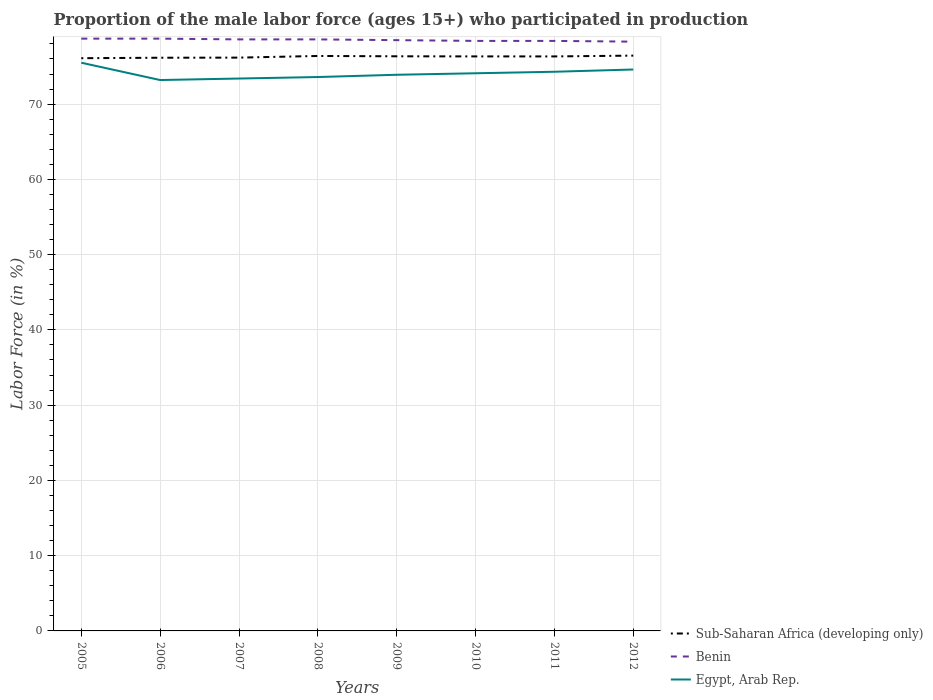Is the number of lines equal to the number of legend labels?
Keep it short and to the point. Yes. Across all years, what is the maximum proportion of the male labor force who participated in production in Egypt, Arab Rep.?
Keep it short and to the point. 73.2. What is the difference between the highest and the second highest proportion of the male labor force who participated in production in Sub-Saharan Africa (developing only)?
Your response must be concise. 0.34. What is the difference between the highest and the lowest proportion of the male labor force who participated in production in Sub-Saharan Africa (developing only)?
Ensure brevity in your answer.  5. Is the proportion of the male labor force who participated in production in Egypt, Arab Rep. strictly greater than the proportion of the male labor force who participated in production in Sub-Saharan Africa (developing only) over the years?
Offer a terse response. Yes. Does the graph contain grids?
Your answer should be very brief. Yes. Where does the legend appear in the graph?
Your response must be concise. Bottom right. How are the legend labels stacked?
Offer a terse response. Vertical. What is the title of the graph?
Keep it short and to the point. Proportion of the male labor force (ages 15+) who participated in production. What is the Labor Force (in %) of Sub-Saharan Africa (developing only) in 2005?
Your response must be concise. 76.1. What is the Labor Force (in %) of Benin in 2005?
Provide a succinct answer. 78.7. What is the Labor Force (in %) of Egypt, Arab Rep. in 2005?
Your answer should be very brief. 75.5. What is the Labor Force (in %) of Sub-Saharan Africa (developing only) in 2006?
Your answer should be compact. 76.16. What is the Labor Force (in %) in Benin in 2006?
Ensure brevity in your answer.  78.7. What is the Labor Force (in %) in Egypt, Arab Rep. in 2006?
Offer a terse response. 73.2. What is the Labor Force (in %) in Sub-Saharan Africa (developing only) in 2007?
Your answer should be compact. 76.18. What is the Labor Force (in %) in Benin in 2007?
Keep it short and to the point. 78.6. What is the Labor Force (in %) in Egypt, Arab Rep. in 2007?
Provide a succinct answer. 73.4. What is the Labor Force (in %) of Sub-Saharan Africa (developing only) in 2008?
Offer a terse response. 76.4. What is the Labor Force (in %) of Benin in 2008?
Provide a succinct answer. 78.6. What is the Labor Force (in %) of Egypt, Arab Rep. in 2008?
Ensure brevity in your answer.  73.6. What is the Labor Force (in %) in Sub-Saharan Africa (developing only) in 2009?
Provide a succinct answer. 76.35. What is the Labor Force (in %) in Benin in 2009?
Make the answer very short. 78.5. What is the Labor Force (in %) in Egypt, Arab Rep. in 2009?
Your answer should be compact. 73.9. What is the Labor Force (in %) of Sub-Saharan Africa (developing only) in 2010?
Your answer should be compact. 76.34. What is the Labor Force (in %) in Benin in 2010?
Your answer should be very brief. 78.4. What is the Labor Force (in %) in Egypt, Arab Rep. in 2010?
Offer a very short reply. 74.1. What is the Labor Force (in %) of Sub-Saharan Africa (developing only) in 2011?
Make the answer very short. 76.34. What is the Labor Force (in %) in Benin in 2011?
Your answer should be very brief. 78.4. What is the Labor Force (in %) of Egypt, Arab Rep. in 2011?
Give a very brief answer. 74.3. What is the Labor Force (in %) in Sub-Saharan Africa (developing only) in 2012?
Keep it short and to the point. 76.44. What is the Labor Force (in %) in Benin in 2012?
Provide a short and direct response. 78.3. What is the Labor Force (in %) in Egypt, Arab Rep. in 2012?
Ensure brevity in your answer.  74.6. Across all years, what is the maximum Labor Force (in %) in Sub-Saharan Africa (developing only)?
Provide a short and direct response. 76.44. Across all years, what is the maximum Labor Force (in %) of Benin?
Offer a terse response. 78.7. Across all years, what is the maximum Labor Force (in %) of Egypt, Arab Rep.?
Give a very brief answer. 75.5. Across all years, what is the minimum Labor Force (in %) in Sub-Saharan Africa (developing only)?
Provide a succinct answer. 76.1. Across all years, what is the minimum Labor Force (in %) in Benin?
Your answer should be very brief. 78.3. Across all years, what is the minimum Labor Force (in %) of Egypt, Arab Rep.?
Provide a succinct answer. 73.2. What is the total Labor Force (in %) of Sub-Saharan Africa (developing only) in the graph?
Provide a succinct answer. 610.32. What is the total Labor Force (in %) in Benin in the graph?
Offer a terse response. 628.2. What is the total Labor Force (in %) of Egypt, Arab Rep. in the graph?
Offer a very short reply. 592.6. What is the difference between the Labor Force (in %) of Sub-Saharan Africa (developing only) in 2005 and that in 2006?
Your answer should be very brief. -0.06. What is the difference between the Labor Force (in %) in Egypt, Arab Rep. in 2005 and that in 2006?
Your answer should be compact. 2.3. What is the difference between the Labor Force (in %) in Sub-Saharan Africa (developing only) in 2005 and that in 2007?
Offer a very short reply. -0.08. What is the difference between the Labor Force (in %) of Benin in 2005 and that in 2007?
Keep it short and to the point. 0.1. What is the difference between the Labor Force (in %) in Egypt, Arab Rep. in 2005 and that in 2007?
Your answer should be very brief. 2.1. What is the difference between the Labor Force (in %) of Sub-Saharan Africa (developing only) in 2005 and that in 2008?
Make the answer very short. -0.3. What is the difference between the Labor Force (in %) in Benin in 2005 and that in 2008?
Your answer should be very brief. 0.1. What is the difference between the Labor Force (in %) of Egypt, Arab Rep. in 2005 and that in 2008?
Your answer should be compact. 1.9. What is the difference between the Labor Force (in %) of Sub-Saharan Africa (developing only) in 2005 and that in 2009?
Your answer should be very brief. -0.25. What is the difference between the Labor Force (in %) of Sub-Saharan Africa (developing only) in 2005 and that in 2010?
Offer a very short reply. -0.24. What is the difference between the Labor Force (in %) of Benin in 2005 and that in 2010?
Offer a very short reply. 0.3. What is the difference between the Labor Force (in %) in Egypt, Arab Rep. in 2005 and that in 2010?
Your response must be concise. 1.4. What is the difference between the Labor Force (in %) in Sub-Saharan Africa (developing only) in 2005 and that in 2011?
Offer a terse response. -0.24. What is the difference between the Labor Force (in %) of Egypt, Arab Rep. in 2005 and that in 2011?
Give a very brief answer. 1.2. What is the difference between the Labor Force (in %) of Sub-Saharan Africa (developing only) in 2005 and that in 2012?
Ensure brevity in your answer.  -0.34. What is the difference between the Labor Force (in %) of Benin in 2005 and that in 2012?
Make the answer very short. 0.4. What is the difference between the Labor Force (in %) of Sub-Saharan Africa (developing only) in 2006 and that in 2007?
Your answer should be compact. -0.02. What is the difference between the Labor Force (in %) of Benin in 2006 and that in 2007?
Give a very brief answer. 0.1. What is the difference between the Labor Force (in %) in Sub-Saharan Africa (developing only) in 2006 and that in 2008?
Make the answer very short. -0.24. What is the difference between the Labor Force (in %) in Egypt, Arab Rep. in 2006 and that in 2008?
Provide a succinct answer. -0.4. What is the difference between the Labor Force (in %) in Sub-Saharan Africa (developing only) in 2006 and that in 2009?
Your answer should be compact. -0.19. What is the difference between the Labor Force (in %) in Egypt, Arab Rep. in 2006 and that in 2009?
Offer a terse response. -0.7. What is the difference between the Labor Force (in %) in Sub-Saharan Africa (developing only) in 2006 and that in 2010?
Ensure brevity in your answer.  -0.18. What is the difference between the Labor Force (in %) in Benin in 2006 and that in 2010?
Provide a short and direct response. 0.3. What is the difference between the Labor Force (in %) of Sub-Saharan Africa (developing only) in 2006 and that in 2011?
Make the answer very short. -0.17. What is the difference between the Labor Force (in %) in Sub-Saharan Africa (developing only) in 2006 and that in 2012?
Your response must be concise. -0.28. What is the difference between the Labor Force (in %) in Sub-Saharan Africa (developing only) in 2007 and that in 2008?
Keep it short and to the point. -0.22. What is the difference between the Labor Force (in %) of Benin in 2007 and that in 2008?
Ensure brevity in your answer.  0. What is the difference between the Labor Force (in %) of Sub-Saharan Africa (developing only) in 2007 and that in 2009?
Provide a succinct answer. -0.18. What is the difference between the Labor Force (in %) in Benin in 2007 and that in 2009?
Give a very brief answer. 0.1. What is the difference between the Labor Force (in %) in Egypt, Arab Rep. in 2007 and that in 2009?
Give a very brief answer. -0.5. What is the difference between the Labor Force (in %) in Sub-Saharan Africa (developing only) in 2007 and that in 2010?
Ensure brevity in your answer.  -0.16. What is the difference between the Labor Force (in %) in Egypt, Arab Rep. in 2007 and that in 2010?
Provide a succinct answer. -0.7. What is the difference between the Labor Force (in %) of Sub-Saharan Africa (developing only) in 2007 and that in 2011?
Your answer should be very brief. -0.16. What is the difference between the Labor Force (in %) of Egypt, Arab Rep. in 2007 and that in 2011?
Keep it short and to the point. -0.9. What is the difference between the Labor Force (in %) in Sub-Saharan Africa (developing only) in 2007 and that in 2012?
Your answer should be very brief. -0.27. What is the difference between the Labor Force (in %) of Egypt, Arab Rep. in 2007 and that in 2012?
Ensure brevity in your answer.  -1.2. What is the difference between the Labor Force (in %) of Sub-Saharan Africa (developing only) in 2008 and that in 2009?
Provide a succinct answer. 0.04. What is the difference between the Labor Force (in %) of Egypt, Arab Rep. in 2008 and that in 2009?
Your response must be concise. -0.3. What is the difference between the Labor Force (in %) in Sub-Saharan Africa (developing only) in 2008 and that in 2010?
Give a very brief answer. 0.06. What is the difference between the Labor Force (in %) of Sub-Saharan Africa (developing only) in 2008 and that in 2011?
Your response must be concise. 0.06. What is the difference between the Labor Force (in %) in Egypt, Arab Rep. in 2008 and that in 2011?
Your answer should be very brief. -0.7. What is the difference between the Labor Force (in %) of Sub-Saharan Africa (developing only) in 2008 and that in 2012?
Provide a short and direct response. -0.05. What is the difference between the Labor Force (in %) in Benin in 2008 and that in 2012?
Make the answer very short. 0.3. What is the difference between the Labor Force (in %) of Sub-Saharan Africa (developing only) in 2009 and that in 2010?
Offer a very short reply. 0.01. What is the difference between the Labor Force (in %) of Egypt, Arab Rep. in 2009 and that in 2010?
Your response must be concise. -0.2. What is the difference between the Labor Force (in %) of Sub-Saharan Africa (developing only) in 2009 and that in 2011?
Provide a short and direct response. 0.02. What is the difference between the Labor Force (in %) in Benin in 2009 and that in 2011?
Your answer should be compact. 0.1. What is the difference between the Labor Force (in %) in Egypt, Arab Rep. in 2009 and that in 2011?
Keep it short and to the point. -0.4. What is the difference between the Labor Force (in %) of Sub-Saharan Africa (developing only) in 2009 and that in 2012?
Keep it short and to the point. -0.09. What is the difference between the Labor Force (in %) in Benin in 2009 and that in 2012?
Make the answer very short. 0.2. What is the difference between the Labor Force (in %) of Egypt, Arab Rep. in 2009 and that in 2012?
Your response must be concise. -0.7. What is the difference between the Labor Force (in %) of Sub-Saharan Africa (developing only) in 2010 and that in 2011?
Ensure brevity in your answer.  0. What is the difference between the Labor Force (in %) of Benin in 2010 and that in 2011?
Offer a terse response. 0. What is the difference between the Labor Force (in %) of Sub-Saharan Africa (developing only) in 2010 and that in 2012?
Your response must be concise. -0.1. What is the difference between the Labor Force (in %) in Benin in 2010 and that in 2012?
Offer a terse response. 0.1. What is the difference between the Labor Force (in %) in Sub-Saharan Africa (developing only) in 2011 and that in 2012?
Your answer should be compact. -0.11. What is the difference between the Labor Force (in %) in Benin in 2011 and that in 2012?
Your answer should be compact. 0.1. What is the difference between the Labor Force (in %) in Egypt, Arab Rep. in 2011 and that in 2012?
Offer a terse response. -0.3. What is the difference between the Labor Force (in %) of Sub-Saharan Africa (developing only) in 2005 and the Labor Force (in %) of Benin in 2006?
Provide a succinct answer. -2.6. What is the difference between the Labor Force (in %) of Sub-Saharan Africa (developing only) in 2005 and the Labor Force (in %) of Egypt, Arab Rep. in 2006?
Your answer should be compact. 2.9. What is the difference between the Labor Force (in %) of Sub-Saharan Africa (developing only) in 2005 and the Labor Force (in %) of Benin in 2007?
Make the answer very short. -2.5. What is the difference between the Labor Force (in %) of Sub-Saharan Africa (developing only) in 2005 and the Labor Force (in %) of Egypt, Arab Rep. in 2007?
Offer a terse response. 2.7. What is the difference between the Labor Force (in %) in Benin in 2005 and the Labor Force (in %) in Egypt, Arab Rep. in 2007?
Your response must be concise. 5.3. What is the difference between the Labor Force (in %) of Sub-Saharan Africa (developing only) in 2005 and the Labor Force (in %) of Benin in 2008?
Make the answer very short. -2.5. What is the difference between the Labor Force (in %) of Sub-Saharan Africa (developing only) in 2005 and the Labor Force (in %) of Egypt, Arab Rep. in 2008?
Your answer should be very brief. 2.5. What is the difference between the Labor Force (in %) in Sub-Saharan Africa (developing only) in 2005 and the Labor Force (in %) in Benin in 2009?
Offer a very short reply. -2.4. What is the difference between the Labor Force (in %) in Sub-Saharan Africa (developing only) in 2005 and the Labor Force (in %) in Egypt, Arab Rep. in 2009?
Your response must be concise. 2.2. What is the difference between the Labor Force (in %) of Sub-Saharan Africa (developing only) in 2005 and the Labor Force (in %) of Benin in 2010?
Your answer should be compact. -2.3. What is the difference between the Labor Force (in %) in Sub-Saharan Africa (developing only) in 2005 and the Labor Force (in %) in Egypt, Arab Rep. in 2010?
Provide a short and direct response. 2. What is the difference between the Labor Force (in %) in Sub-Saharan Africa (developing only) in 2005 and the Labor Force (in %) in Benin in 2011?
Make the answer very short. -2.3. What is the difference between the Labor Force (in %) in Sub-Saharan Africa (developing only) in 2005 and the Labor Force (in %) in Egypt, Arab Rep. in 2011?
Give a very brief answer. 1.8. What is the difference between the Labor Force (in %) in Benin in 2005 and the Labor Force (in %) in Egypt, Arab Rep. in 2011?
Your answer should be compact. 4.4. What is the difference between the Labor Force (in %) in Sub-Saharan Africa (developing only) in 2005 and the Labor Force (in %) in Benin in 2012?
Keep it short and to the point. -2.2. What is the difference between the Labor Force (in %) in Sub-Saharan Africa (developing only) in 2005 and the Labor Force (in %) in Egypt, Arab Rep. in 2012?
Your answer should be very brief. 1.5. What is the difference between the Labor Force (in %) of Benin in 2005 and the Labor Force (in %) of Egypt, Arab Rep. in 2012?
Your response must be concise. 4.1. What is the difference between the Labor Force (in %) in Sub-Saharan Africa (developing only) in 2006 and the Labor Force (in %) in Benin in 2007?
Offer a terse response. -2.44. What is the difference between the Labor Force (in %) in Sub-Saharan Africa (developing only) in 2006 and the Labor Force (in %) in Egypt, Arab Rep. in 2007?
Offer a very short reply. 2.76. What is the difference between the Labor Force (in %) of Sub-Saharan Africa (developing only) in 2006 and the Labor Force (in %) of Benin in 2008?
Make the answer very short. -2.44. What is the difference between the Labor Force (in %) of Sub-Saharan Africa (developing only) in 2006 and the Labor Force (in %) of Egypt, Arab Rep. in 2008?
Make the answer very short. 2.56. What is the difference between the Labor Force (in %) in Sub-Saharan Africa (developing only) in 2006 and the Labor Force (in %) in Benin in 2009?
Provide a short and direct response. -2.34. What is the difference between the Labor Force (in %) of Sub-Saharan Africa (developing only) in 2006 and the Labor Force (in %) of Egypt, Arab Rep. in 2009?
Make the answer very short. 2.26. What is the difference between the Labor Force (in %) in Sub-Saharan Africa (developing only) in 2006 and the Labor Force (in %) in Benin in 2010?
Provide a short and direct response. -2.24. What is the difference between the Labor Force (in %) in Sub-Saharan Africa (developing only) in 2006 and the Labor Force (in %) in Egypt, Arab Rep. in 2010?
Your answer should be very brief. 2.06. What is the difference between the Labor Force (in %) in Benin in 2006 and the Labor Force (in %) in Egypt, Arab Rep. in 2010?
Keep it short and to the point. 4.6. What is the difference between the Labor Force (in %) in Sub-Saharan Africa (developing only) in 2006 and the Labor Force (in %) in Benin in 2011?
Give a very brief answer. -2.24. What is the difference between the Labor Force (in %) in Sub-Saharan Africa (developing only) in 2006 and the Labor Force (in %) in Egypt, Arab Rep. in 2011?
Provide a short and direct response. 1.86. What is the difference between the Labor Force (in %) of Benin in 2006 and the Labor Force (in %) of Egypt, Arab Rep. in 2011?
Give a very brief answer. 4.4. What is the difference between the Labor Force (in %) in Sub-Saharan Africa (developing only) in 2006 and the Labor Force (in %) in Benin in 2012?
Your answer should be very brief. -2.14. What is the difference between the Labor Force (in %) of Sub-Saharan Africa (developing only) in 2006 and the Labor Force (in %) of Egypt, Arab Rep. in 2012?
Your answer should be compact. 1.56. What is the difference between the Labor Force (in %) of Sub-Saharan Africa (developing only) in 2007 and the Labor Force (in %) of Benin in 2008?
Provide a succinct answer. -2.42. What is the difference between the Labor Force (in %) in Sub-Saharan Africa (developing only) in 2007 and the Labor Force (in %) in Egypt, Arab Rep. in 2008?
Make the answer very short. 2.58. What is the difference between the Labor Force (in %) of Sub-Saharan Africa (developing only) in 2007 and the Labor Force (in %) of Benin in 2009?
Offer a terse response. -2.32. What is the difference between the Labor Force (in %) in Sub-Saharan Africa (developing only) in 2007 and the Labor Force (in %) in Egypt, Arab Rep. in 2009?
Give a very brief answer. 2.28. What is the difference between the Labor Force (in %) of Benin in 2007 and the Labor Force (in %) of Egypt, Arab Rep. in 2009?
Your answer should be very brief. 4.7. What is the difference between the Labor Force (in %) in Sub-Saharan Africa (developing only) in 2007 and the Labor Force (in %) in Benin in 2010?
Your answer should be very brief. -2.22. What is the difference between the Labor Force (in %) in Sub-Saharan Africa (developing only) in 2007 and the Labor Force (in %) in Egypt, Arab Rep. in 2010?
Your response must be concise. 2.08. What is the difference between the Labor Force (in %) in Benin in 2007 and the Labor Force (in %) in Egypt, Arab Rep. in 2010?
Give a very brief answer. 4.5. What is the difference between the Labor Force (in %) of Sub-Saharan Africa (developing only) in 2007 and the Labor Force (in %) of Benin in 2011?
Make the answer very short. -2.22. What is the difference between the Labor Force (in %) of Sub-Saharan Africa (developing only) in 2007 and the Labor Force (in %) of Egypt, Arab Rep. in 2011?
Keep it short and to the point. 1.88. What is the difference between the Labor Force (in %) of Sub-Saharan Africa (developing only) in 2007 and the Labor Force (in %) of Benin in 2012?
Your answer should be very brief. -2.12. What is the difference between the Labor Force (in %) of Sub-Saharan Africa (developing only) in 2007 and the Labor Force (in %) of Egypt, Arab Rep. in 2012?
Your answer should be compact. 1.58. What is the difference between the Labor Force (in %) of Benin in 2007 and the Labor Force (in %) of Egypt, Arab Rep. in 2012?
Offer a terse response. 4. What is the difference between the Labor Force (in %) in Sub-Saharan Africa (developing only) in 2008 and the Labor Force (in %) in Benin in 2009?
Ensure brevity in your answer.  -2.1. What is the difference between the Labor Force (in %) in Sub-Saharan Africa (developing only) in 2008 and the Labor Force (in %) in Egypt, Arab Rep. in 2009?
Provide a succinct answer. 2.5. What is the difference between the Labor Force (in %) in Benin in 2008 and the Labor Force (in %) in Egypt, Arab Rep. in 2009?
Offer a very short reply. 4.7. What is the difference between the Labor Force (in %) of Sub-Saharan Africa (developing only) in 2008 and the Labor Force (in %) of Benin in 2010?
Offer a terse response. -2. What is the difference between the Labor Force (in %) in Sub-Saharan Africa (developing only) in 2008 and the Labor Force (in %) in Egypt, Arab Rep. in 2010?
Ensure brevity in your answer.  2.3. What is the difference between the Labor Force (in %) in Benin in 2008 and the Labor Force (in %) in Egypt, Arab Rep. in 2010?
Offer a terse response. 4.5. What is the difference between the Labor Force (in %) of Sub-Saharan Africa (developing only) in 2008 and the Labor Force (in %) of Benin in 2011?
Offer a terse response. -2. What is the difference between the Labor Force (in %) of Sub-Saharan Africa (developing only) in 2008 and the Labor Force (in %) of Egypt, Arab Rep. in 2011?
Ensure brevity in your answer.  2.1. What is the difference between the Labor Force (in %) of Benin in 2008 and the Labor Force (in %) of Egypt, Arab Rep. in 2011?
Keep it short and to the point. 4.3. What is the difference between the Labor Force (in %) in Sub-Saharan Africa (developing only) in 2008 and the Labor Force (in %) in Benin in 2012?
Make the answer very short. -1.9. What is the difference between the Labor Force (in %) of Sub-Saharan Africa (developing only) in 2008 and the Labor Force (in %) of Egypt, Arab Rep. in 2012?
Your answer should be compact. 1.8. What is the difference between the Labor Force (in %) of Benin in 2008 and the Labor Force (in %) of Egypt, Arab Rep. in 2012?
Make the answer very short. 4. What is the difference between the Labor Force (in %) of Sub-Saharan Africa (developing only) in 2009 and the Labor Force (in %) of Benin in 2010?
Offer a very short reply. -2.05. What is the difference between the Labor Force (in %) of Sub-Saharan Africa (developing only) in 2009 and the Labor Force (in %) of Egypt, Arab Rep. in 2010?
Your answer should be very brief. 2.25. What is the difference between the Labor Force (in %) of Benin in 2009 and the Labor Force (in %) of Egypt, Arab Rep. in 2010?
Your answer should be compact. 4.4. What is the difference between the Labor Force (in %) of Sub-Saharan Africa (developing only) in 2009 and the Labor Force (in %) of Benin in 2011?
Give a very brief answer. -2.05. What is the difference between the Labor Force (in %) in Sub-Saharan Africa (developing only) in 2009 and the Labor Force (in %) in Egypt, Arab Rep. in 2011?
Your response must be concise. 2.05. What is the difference between the Labor Force (in %) in Benin in 2009 and the Labor Force (in %) in Egypt, Arab Rep. in 2011?
Provide a succinct answer. 4.2. What is the difference between the Labor Force (in %) of Sub-Saharan Africa (developing only) in 2009 and the Labor Force (in %) of Benin in 2012?
Keep it short and to the point. -1.95. What is the difference between the Labor Force (in %) in Sub-Saharan Africa (developing only) in 2009 and the Labor Force (in %) in Egypt, Arab Rep. in 2012?
Your response must be concise. 1.75. What is the difference between the Labor Force (in %) in Sub-Saharan Africa (developing only) in 2010 and the Labor Force (in %) in Benin in 2011?
Make the answer very short. -2.06. What is the difference between the Labor Force (in %) in Sub-Saharan Africa (developing only) in 2010 and the Labor Force (in %) in Egypt, Arab Rep. in 2011?
Give a very brief answer. 2.04. What is the difference between the Labor Force (in %) in Sub-Saharan Africa (developing only) in 2010 and the Labor Force (in %) in Benin in 2012?
Give a very brief answer. -1.96. What is the difference between the Labor Force (in %) in Sub-Saharan Africa (developing only) in 2010 and the Labor Force (in %) in Egypt, Arab Rep. in 2012?
Your response must be concise. 1.74. What is the difference between the Labor Force (in %) in Benin in 2010 and the Labor Force (in %) in Egypt, Arab Rep. in 2012?
Provide a succinct answer. 3.8. What is the difference between the Labor Force (in %) in Sub-Saharan Africa (developing only) in 2011 and the Labor Force (in %) in Benin in 2012?
Give a very brief answer. -1.96. What is the difference between the Labor Force (in %) in Sub-Saharan Africa (developing only) in 2011 and the Labor Force (in %) in Egypt, Arab Rep. in 2012?
Your answer should be very brief. 1.74. What is the difference between the Labor Force (in %) in Benin in 2011 and the Labor Force (in %) in Egypt, Arab Rep. in 2012?
Make the answer very short. 3.8. What is the average Labor Force (in %) of Sub-Saharan Africa (developing only) per year?
Make the answer very short. 76.29. What is the average Labor Force (in %) in Benin per year?
Your response must be concise. 78.53. What is the average Labor Force (in %) in Egypt, Arab Rep. per year?
Provide a succinct answer. 74.08. In the year 2005, what is the difference between the Labor Force (in %) of Sub-Saharan Africa (developing only) and Labor Force (in %) of Benin?
Make the answer very short. -2.6. In the year 2005, what is the difference between the Labor Force (in %) of Sub-Saharan Africa (developing only) and Labor Force (in %) of Egypt, Arab Rep.?
Ensure brevity in your answer.  0.6. In the year 2006, what is the difference between the Labor Force (in %) of Sub-Saharan Africa (developing only) and Labor Force (in %) of Benin?
Your answer should be very brief. -2.54. In the year 2006, what is the difference between the Labor Force (in %) in Sub-Saharan Africa (developing only) and Labor Force (in %) in Egypt, Arab Rep.?
Provide a short and direct response. 2.96. In the year 2007, what is the difference between the Labor Force (in %) of Sub-Saharan Africa (developing only) and Labor Force (in %) of Benin?
Make the answer very short. -2.42. In the year 2007, what is the difference between the Labor Force (in %) of Sub-Saharan Africa (developing only) and Labor Force (in %) of Egypt, Arab Rep.?
Provide a succinct answer. 2.78. In the year 2007, what is the difference between the Labor Force (in %) in Benin and Labor Force (in %) in Egypt, Arab Rep.?
Your answer should be very brief. 5.2. In the year 2008, what is the difference between the Labor Force (in %) of Sub-Saharan Africa (developing only) and Labor Force (in %) of Benin?
Make the answer very short. -2.2. In the year 2008, what is the difference between the Labor Force (in %) in Sub-Saharan Africa (developing only) and Labor Force (in %) in Egypt, Arab Rep.?
Keep it short and to the point. 2.8. In the year 2008, what is the difference between the Labor Force (in %) of Benin and Labor Force (in %) of Egypt, Arab Rep.?
Your answer should be compact. 5. In the year 2009, what is the difference between the Labor Force (in %) of Sub-Saharan Africa (developing only) and Labor Force (in %) of Benin?
Give a very brief answer. -2.15. In the year 2009, what is the difference between the Labor Force (in %) in Sub-Saharan Africa (developing only) and Labor Force (in %) in Egypt, Arab Rep.?
Offer a terse response. 2.45. In the year 2009, what is the difference between the Labor Force (in %) in Benin and Labor Force (in %) in Egypt, Arab Rep.?
Give a very brief answer. 4.6. In the year 2010, what is the difference between the Labor Force (in %) of Sub-Saharan Africa (developing only) and Labor Force (in %) of Benin?
Give a very brief answer. -2.06. In the year 2010, what is the difference between the Labor Force (in %) of Sub-Saharan Africa (developing only) and Labor Force (in %) of Egypt, Arab Rep.?
Make the answer very short. 2.24. In the year 2011, what is the difference between the Labor Force (in %) of Sub-Saharan Africa (developing only) and Labor Force (in %) of Benin?
Make the answer very short. -2.06. In the year 2011, what is the difference between the Labor Force (in %) of Sub-Saharan Africa (developing only) and Labor Force (in %) of Egypt, Arab Rep.?
Your answer should be very brief. 2.04. In the year 2012, what is the difference between the Labor Force (in %) in Sub-Saharan Africa (developing only) and Labor Force (in %) in Benin?
Provide a succinct answer. -1.86. In the year 2012, what is the difference between the Labor Force (in %) in Sub-Saharan Africa (developing only) and Labor Force (in %) in Egypt, Arab Rep.?
Your answer should be very brief. 1.84. What is the ratio of the Labor Force (in %) in Benin in 2005 to that in 2006?
Make the answer very short. 1. What is the ratio of the Labor Force (in %) in Egypt, Arab Rep. in 2005 to that in 2006?
Your answer should be compact. 1.03. What is the ratio of the Labor Force (in %) of Sub-Saharan Africa (developing only) in 2005 to that in 2007?
Offer a terse response. 1. What is the ratio of the Labor Force (in %) of Egypt, Arab Rep. in 2005 to that in 2007?
Your answer should be very brief. 1.03. What is the ratio of the Labor Force (in %) in Sub-Saharan Africa (developing only) in 2005 to that in 2008?
Keep it short and to the point. 1. What is the ratio of the Labor Force (in %) in Benin in 2005 to that in 2008?
Make the answer very short. 1. What is the ratio of the Labor Force (in %) of Egypt, Arab Rep. in 2005 to that in 2008?
Keep it short and to the point. 1.03. What is the ratio of the Labor Force (in %) in Sub-Saharan Africa (developing only) in 2005 to that in 2009?
Provide a short and direct response. 1. What is the ratio of the Labor Force (in %) of Egypt, Arab Rep. in 2005 to that in 2009?
Give a very brief answer. 1.02. What is the ratio of the Labor Force (in %) in Sub-Saharan Africa (developing only) in 2005 to that in 2010?
Your response must be concise. 1. What is the ratio of the Labor Force (in %) in Benin in 2005 to that in 2010?
Your response must be concise. 1. What is the ratio of the Labor Force (in %) in Egypt, Arab Rep. in 2005 to that in 2010?
Ensure brevity in your answer.  1.02. What is the ratio of the Labor Force (in %) of Benin in 2005 to that in 2011?
Keep it short and to the point. 1. What is the ratio of the Labor Force (in %) in Egypt, Arab Rep. in 2005 to that in 2011?
Your response must be concise. 1.02. What is the ratio of the Labor Force (in %) of Benin in 2005 to that in 2012?
Your answer should be very brief. 1.01. What is the ratio of the Labor Force (in %) of Egypt, Arab Rep. in 2005 to that in 2012?
Offer a very short reply. 1.01. What is the ratio of the Labor Force (in %) of Sub-Saharan Africa (developing only) in 2006 to that in 2007?
Your response must be concise. 1. What is the ratio of the Labor Force (in %) of Egypt, Arab Rep. in 2006 to that in 2007?
Give a very brief answer. 1. What is the ratio of the Labor Force (in %) in Sub-Saharan Africa (developing only) in 2006 to that in 2009?
Your answer should be compact. 1. What is the ratio of the Labor Force (in %) in Benin in 2006 to that in 2009?
Give a very brief answer. 1. What is the ratio of the Labor Force (in %) of Sub-Saharan Africa (developing only) in 2006 to that in 2010?
Provide a short and direct response. 1. What is the ratio of the Labor Force (in %) of Benin in 2006 to that in 2010?
Your answer should be compact. 1. What is the ratio of the Labor Force (in %) in Egypt, Arab Rep. in 2006 to that in 2010?
Provide a succinct answer. 0.99. What is the ratio of the Labor Force (in %) in Sub-Saharan Africa (developing only) in 2006 to that in 2011?
Offer a very short reply. 1. What is the ratio of the Labor Force (in %) in Benin in 2006 to that in 2011?
Provide a short and direct response. 1. What is the ratio of the Labor Force (in %) in Egypt, Arab Rep. in 2006 to that in 2011?
Provide a succinct answer. 0.99. What is the ratio of the Labor Force (in %) of Sub-Saharan Africa (developing only) in 2006 to that in 2012?
Keep it short and to the point. 1. What is the ratio of the Labor Force (in %) of Egypt, Arab Rep. in 2006 to that in 2012?
Give a very brief answer. 0.98. What is the ratio of the Labor Force (in %) of Sub-Saharan Africa (developing only) in 2007 to that in 2008?
Your answer should be very brief. 1. What is the ratio of the Labor Force (in %) of Egypt, Arab Rep. in 2007 to that in 2010?
Keep it short and to the point. 0.99. What is the ratio of the Labor Force (in %) in Egypt, Arab Rep. in 2007 to that in 2011?
Provide a short and direct response. 0.99. What is the ratio of the Labor Force (in %) in Sub-Saharan Africa (developing only) in 2007 to that in 2012?
Provide a succinct answer. 1. What is the ratio of the Labor Force (in %) of Benin in 2007 to that in 2012?
Make the answer very short. 1. What is the ratio of the Labor Force (in %) of Egypt, Arab Rep. in 2007 to that in 2012?
Offer a terse response. 0.98. What is the ratio of the Labor Force (in %) in Egypt, Arab Rep. in 2008 to that in 2009?
Ensure brevity in your answer.  1. What is the ratio of the Labor Force (in %) of Sub-Saharan Africa (developing only) in 2008 to that in 2010?
Offer a very short reply. 1. What is the ratio of the Labor Force (in %) of Benin in 2008 to that in 2011?
Offer a terse response. 1. What is the ratio of the Labor Force (in %) of Egypt, Arab Rep. in 2008 to that in 2011?
Your answer should be very brief. 0.99. What is the ratio of the Labor Force (in %) in Egypt, Arab Rep. in 2008 to that in 2012?
Offer a very short reply. 0.99. What is the ratio of the Labor Force (in %) in Egypt, Arab Rep. in 2009 to that in 2010?
Your answer should be very brief. 1. What is the ratio of the Labor Force (in %) in Egypt, Arab Rep. in 2009 to that in 2011?
Provide a succinct answer. 0.99. What is the ratio of the Labor Force (in %) in Egypt, Arab Rep. in 2009 to that in 2012?
Give a very brief answer. 0.99. What is the ratio of the Labor Force (in %) of Benin in 2010 to that in 2011?
Offer a very short reply. 1. What is the ratio of the Labor Force (in %) of Benin in 2010 to that in 2012?
Your response must be concise. 1. What is the ratio of the Labor Force (in %) in Egypt, Arab Rep. in 2010 to that in 2012?
Provide a short and direct response. 0.99. What is the ratio of the Labor Force (in %) in Sub-Saharan Africa (developing only) in 2011 to that in 2012?
Keep it short and to the point. 1. What is the ratio of the Labor Force (in %) of Benin in 2011 to that in 2012?
Your answer should be very brief. 1. What is the difference between the highest and the second highest Labor Force (in %) in Sub-Saharan Africa (developing only)?
Your answer should be compact. 0.05. What is the difference between the highest and the lowest Labor Force (in %) in Sub-Saharan Africa (developing only)?
Ensure brevity in your answer.  0.34. What is the difference between the highest and the lowest Labor Force (in %) of Benin?
Make the answer very short. 0.4. What is the difference between the highest and the lowest Labor Force (in %) of Egypt, Arab Rep.?
Ensure brevity in your answer.  2.3. 